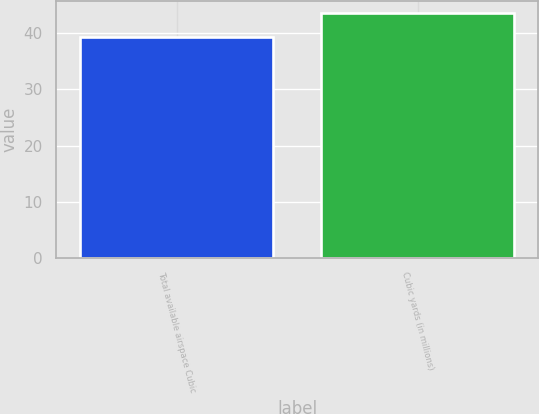Convert chart. <chart><loc_0><loc_0><loc_500><loc_500><bar_chart><fcel>Total available airspace Cubic<fcel>Cubic yards (in millions)<nl><fcel>39.3<fcel>43.6<nl></chart> 